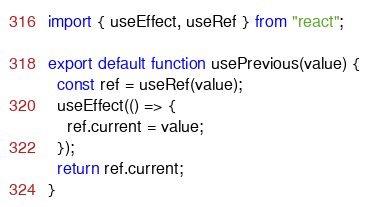<code> <loc_0><loc_0><loc_500><loc_500><_JavaScript_>import { useEffect, useRef } from "react";

export default function usePrevious(value) {
  const ref = useRef(value);
  useEffect(() => {
    ref.current = value;
  });
  return ref.current;
}
</code> 